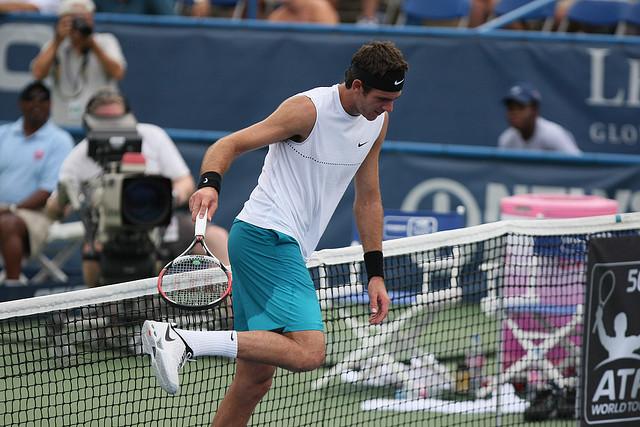What is the tennis player wearing on their legs?
Keep it brief. Socks. What is he holding in his right hand?
Answer briefly. Racket. What gender is the player?
Keep it brief. Male. Are they playing doubles?
Short answer required. No. What is the player about to do?
Give a very brief answer. Play tennis. Why is he sweating?
Concise answer only. Playing tennis. Is the guy wearing a hat?
Answer briefly. No. Did this man win or lose?
Be succinct. Win. 